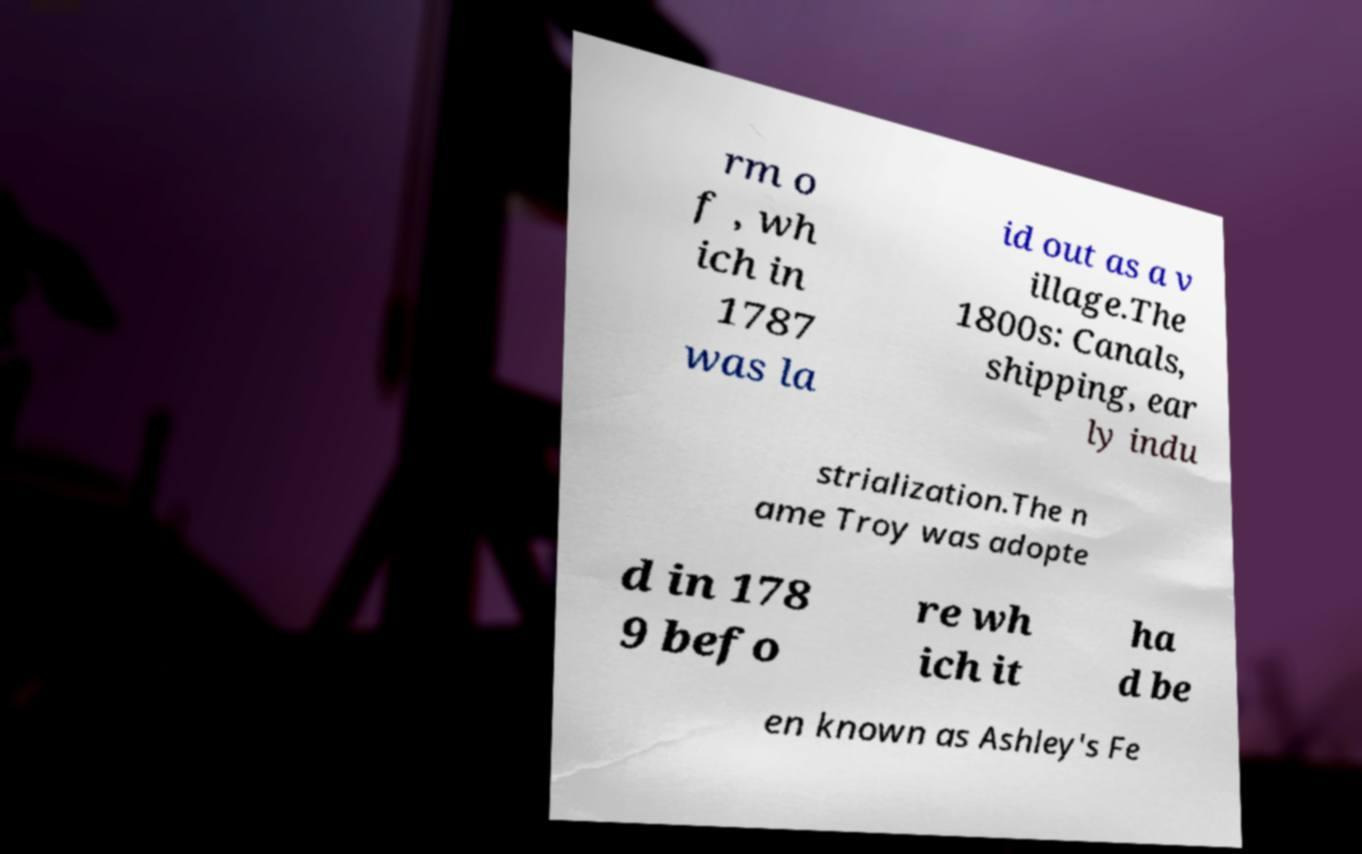What messages or text are displayed in this image? I need them in a readable, typed format. rm o f , wh ich in 1787 was la id out as a v illage.The 1800s: Canals, shipping, ear ly indu strialization.The n ame Troy was adopte d in 178 9 befo re wh ich it ha d be en known as Ashley's Fe 